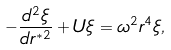Convert formula to latex. <formula><loc_0><loc_0><loc_500><loc_500>- \frac { d ^ { 2 } \xi } { d r ^ { * 2 } } + U \xi = \omega ^ { 2 } r ^ { 4 } \xi ,</formula> 